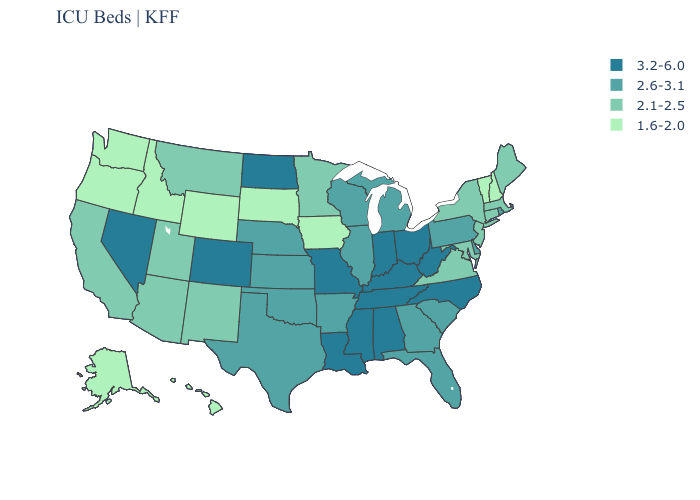Does the first symbol in the legend represent the smallest category?
Quick response, please. No. Which states hav the highest value in the Northeast?
Concise answer only. Pennsylvania, Rhode Island. What is the value of Iowa?
Answer briefly. 1.6-2.0. What is the value of Vermont?
Concise answer only. 1.6-2.0. What is the lowest value in states that border Delaware?
Write a very short answer. 2.1-2.5. How many symbols are there in the legend?
Give a very brief answer. 4. Name the states that have a value in the range 2.6-3.1?
Be succinct. Arkansas, Delaware, Florida, Georgia, Illinois, Kansas, Michigan, Nebraska, Oklahoma, Pennsylvania, Rhode Island, South Carolina, Texas, Wisconsin. What is the value of Illinois?
Answer briefly. 2.6-3.1. Does Arizona have the lowest value in the West?
Write a very short answer. No. What is the highest value in the USA?
Write a very short answer. 3.2-6.0. Among the states that border Colorado , does Wyoming have the lowest value?
Write a very short answer. Yes. Name the states that have a value in the range 2.1-2.5?
Keep it brief. Arizona, California, Connecticut, Maine, Maryland, Massachusetts, Minnesota, Montana, New Jersey, New Mexico, New York, Utah, Virginia. What is the lowest value in states that border Kentucky?
Give a very brief answer. 2.1-2.5. What is the lowest value in the USA?
Short answer required. 1.6-2.0. Name the states that have a value in the range 1.6-2.0?
Quick response, please. Alaska, Hawaii, Idaho, Iowa, New Hampshire, Oregon, South Dakota, Vermont, Washington, Wyoming. 